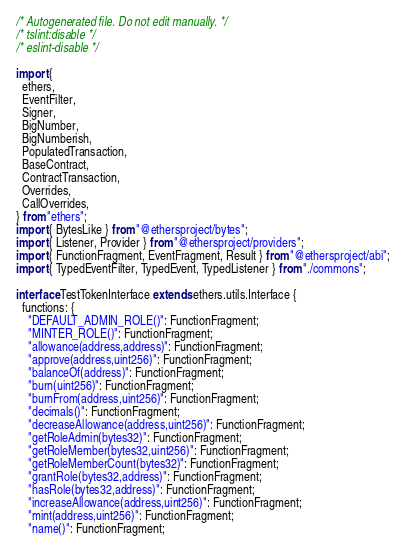Convert code to text. <code><loc_0><loc_0><loc_500><loc_500><_TypeScript_>/* Autogenerated file. Do not edit manually. */
/* tslint:disable */
/* eslint-disable */

import {
  ethers,
  EventFilter,
  Signer,
  BigNumber,
  BigNumberish,
  PopulatedTransaction,
  BaseContract,
  ContractTransaction,
  Overrides,
  CallOverrides,
} from "ethers";
import { BytesLike } from "@ethersproject/bytes";
import { Listener, Provider } from "@ethersproject/providers";
import { FunctionFragment, EventFragment, Result } from "@ethersproject/abi";
import { TypedEventFilter, TypedEvent, TypedListener } from "./commons";

interface TestTokenInterface extends ethers.utils.Interface {
  functions: {
    "DEFAULT_ADMIN_ROLE()": FunctionFragment;
    "MINTER_ROLE()": FunctionFragment;
    "allowance(address,address)": FunctionFragment;
    "approve(address,uint256)": FunctionFragment;
    "balanceOf(address)": FunctionFragment;
    "burn(uint256)": FunctionFragment;
    "burnFrom(address,uint256)": FunctionFragment;
    "decimals()": FunctionFragment;
    "decreaseAllowance(address,uint256)": FunctionFragment;
    "getRoleAdmin(bytes32)": FunctionFragment;
    "getRoleMember(bytes32,uint256)": FunctionFragment;
    "getRoleMemberCount(bytes32)": FunctionFragment;
    "grantRole(bytes32,address)": FunctionFragment;
    "hasRole(bytes32,address)": FunctionFragment;
    "increaseAllowance(address,uint256)": FunctionFragment;
    "mint(address,uint256)": FunctionFragment;
    "name()": FunctionFragment;</code> 